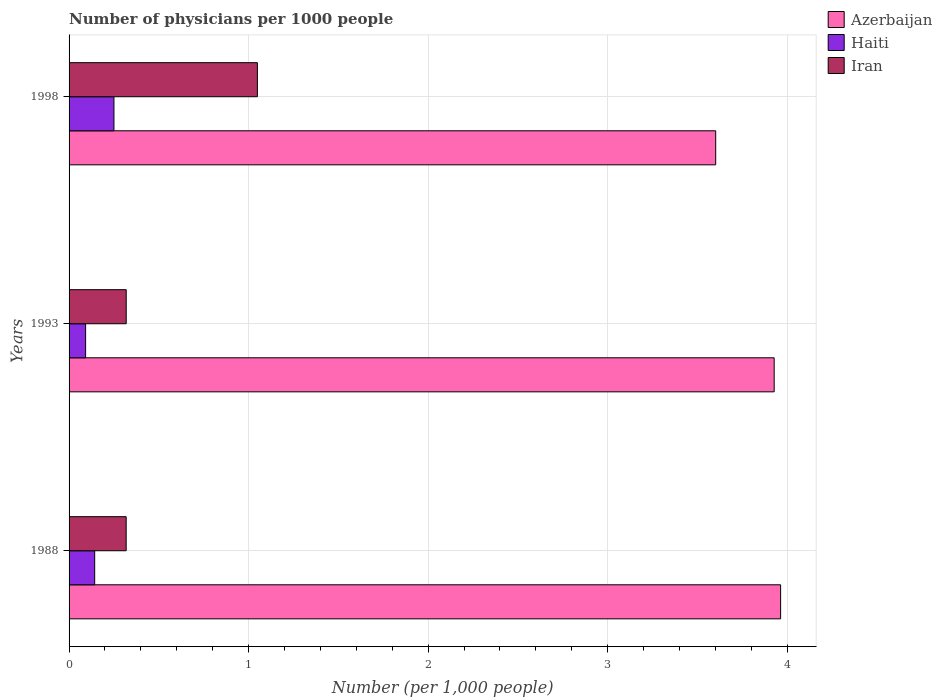Are the number of bars per tick equal to the number of legend labels?
Provide a succinct answer. Yes. How many bars are there on the 3rd tick from the bottom?
Your answer should be very brief. 3. What is the label of the 2nd group of bars from the top?
Make the answer very short. 1993. In how many cases, is the number of bars for a given year not equal to the number of legend labels?
Keep it short and to the point. 0. What is the number of physicians in Azerbaijan in 1988?
Ensure brevity in your answer.  3.96. Across all years, what is the maximum number of physicians in Haiti?
Offer a very short reply. 0.25. Across all years, what is the minimum number of physicians in Haiti?
Make the answer very short. 0.09. What is the total number of physicians in Azerbaijan in the graph?
Ensure brevity in your answer.  11.49. What is the difference between the number of physicians in Azerbaijan in 1988 and that in 1998?
Provide a short and direct response. 0.36. What is the difference between the number of physicians in Iran in 1993 and the number of physicians in Azerbaijan in 1998?
Offer a terse response. -3.28. What is the average number of physicians in Iran per year?
Your answer should be compact. 0.56. In the year 1998, what is the difference between the number of physicians in Iran and number of physicians in Azerbaijan?
Your answer should be compact. -2.55. In how many years, is the number of physicians in Iran greater than 2.4 ?
Make the answer very short. 0. What is the ratio of the number of physicians in Azerbaijan in 1993 to that in 1998?
Keep it short and to the point. 1.09. Is the difference between the number of physicians in Iran in 1993 and 1998 greater than the difference between the number of physicians in Azerbaijan in 1993 and 1998?
Offer a terse response. No. What is the difference between the highest and the second highest number of physicians in Haiti?
Provide a short and direct response. 0.11. What is the difference between the highest and the lowest number of physicians in Haiti?
Provide a short and direct response. 0.16. Is the sum of the number of physicians in Iran in 1988 and 1998 greater than the maximum number of physicians in Azerbaijan across all years?
Your response must be concise. No. What does the 3rd bar from the top in 1988 represents?
Ensure brevity in your answer.  Azerbaijan. What does the 2nd bar from the bottom in 1993 represents?
Give a very brief answer. Haiti. Does the graph contain grids?
Your answer should be very brief. Yes. How many legend labels are there?
Offer a very short reply. 3. What is the title of the graph?
Ensure brevity in your answer.  Number of physicians per 1000 people. What is the label or title of the X-axis?
Ensure brevity in your answer.  Number (per 1,0 people). What is the Number (per 1,000 people) of Azerbaijan in 1988?
Offer a very short reply. 3.96. What is the Number (per 1,000 people) in Haiti in 1988?
Make the answer very short. 0.14. What is the Number (per 1,000 people) of Iran in 1988?
Your response must be concise. 0.32. What is the Number (per 1,000 people) of Azerbaijan in 1993?
Ensure brevity in your answer.  3.93. What is the Number (per 1,000 people) in Haiti in 1993?
Offer a very short reply. 0.09. What is the Number (per 1,000 people) of Iran in 1993?
Provide a succinct answer. 0.32. What is the Number (per 1,000 people) in Azerbaijan in 1998?
Ensure brevity in your answer.  3.6. What is the Number (per 1,000 people) of Iran in 1998?
Keep it short and to the point. 1.05. Across all years, what is the maximum Number (per 1,000 people) of Azerbaijan?
Offer a very short reply. 3.96. Across all years, what is the maximum Number (per 1,000 people) of Iran?
Your response must be concise. 1.05. Across all years, what is the minimum Number (per 1,000 people) in Azerbaijan?
Your answer should be compact. 3.6. Across all years, what is the minimum Number (per 1,000 people) in Haiti?
Provide a short and direct response. 0.09. Across all years, what is the minimum Number (per 1,000 people) in Iran?
Ensure brevity in your answer.  0.32. What is the total Number (per 1,000 people) of Azerbaijan in the graph?
Provide a succinct answer. 11.49. What is the total Number (per 1,000 people) of Haiti in the graph?
Provide a succinct answer. 0.48. What is the total Number (per 1,000 people) of Iran in the graph?
Give a very brief answer. 1.69. What is the difference between the Number (per 1,000 people) in Azerbaijan in 1988 and that in 1993?
Offer a terse response. 0.04. What is the difference between the Number (per 1,000 people) of Haiti in 1988 and that in 1993?
Provide a short and direct response. 0.05. What is the difference between the Number (per 1,000 people) in Iran in 1988 and that in 1993?
Provide a succinct answer. -0. What is the difference between the Number (per 1,000 people) in Azerbaijan in 1988 and that in 1998?
Ensure brevity in your answer.  0.36. What is the difference between the Number (per 1,000 people) in Haiti in 1988 and that in 1998?
Your response must be concise. -0.11. What is the difference between the Number (per 1,000 people) of Iran in 1988 and that in 1998?
Provide a succinct answer. -0.73. What is the difference between the Number (per 1,000 people) of Azerbaijan in 1993 and that in 1998?
Keep it short and to the point. 0.33. What is the difference between the Number (per 1,000 people) of Haiti in 1993 and that in 1998?
Your answer should be very brief. -0.16. What is the difference between the Number (per 1,000 people) in Iran in 1993 and that in 1998?
Offer a terse response. -0.73. What is the difference between the Number (per 1,000 people) of Azerbaijan in 1988 and the Number (per 1,000 people) of Haiti in 1993?
Your response must be concise. 3.87. What is the difference between the Number (per 1,000 people) of Azerbaijan in 1988 and the Number (per 1,000 people) of Iran in 1993?
Keep it short and to the point. 3.65. What is the difference between the Number (per 1,000 people) of Haiti in 1988 and the Number (per 1,000 people) of Iran in 1993?
Give a very brief answer. -0.18. What is the difference between the Number (per 1,000 people) of Azerbaijan in 1988 and the Number (per 1,000 people) of Haiti in 1998?
Your answer should be very brief. 3.71. What is the difference between the Number (per 1,000 people) of Azerbaijan in 1988 and the Number (per 1,000 people) of Iran in 1998?
Offer a terse response. 2.91. What is the difference between the Number (per 1,000 people) in Haiti in 1988 and the Number (per 1,000 people) in Iran in 1998?
Offer a terse response. -0.91. What is the difference between the Number (per 1,000 people) of Azerbaijan in 1993 and the Number (per 1,000 people) of Haiti in 1998?
Offer a terse response. 3.68. What is the difference between the Number (per 1,000 people) in Azerbaijan in 1993 and the Number (per 1,000 people) in Iran in 1998?
Your answer should be compact. 2.88. What is the difference between the Number (per 1,000 people) in Haiti in 1993 and the Number (per 1,000 people) in Iran in 1998?
Make the answer very short. -0.96. What is the average Number (per 1,000 people) of Azerbaijan per year?
Ensure brevity in your answer.  3.83. What is the average Number (per 1,000 people) in Haiti per year?
Give a very brief answer. 0.16. What is the average Number (per 1,000 people) of Iran per year?
Your answer should be very brief. 0.56. In the year 1988, what is the difference between the Number (per 1,000 people) of Azerbaijan and Number (per 1,000 people) of Haiti?
Give a very brief answer. 3.82. In the year 1988, what is the difference between the Number (per 1,000 people) in Azerbaijan and Number (per 1,000 people) in Iran?
Offer a very short reply. 3.65. In the year 1988, what is the difference between the Number (per 1,000 people) in Haiti and Number (per 1,000 people) in Iran?
Offer a terse response. -0.18. In the year 1993, what is the difference between the Number (per 1,000 people) of Azerbaijan and Number (per 1,000 people) of Haiti?
Offer a terse response. 3.84. In the year 1993, what is the difference between the Number (per 1,000 people) in Azerbaijan and Number (per 1,000 people) in Iran?
Make the answer very short. 3.61. In the year 1993, what is the difference between the Number (per 1,000 people) of Haiti and Number (per 1,000 people) of Iran?
Your answer should be very brief. -0.23. In the year 1998, what is the difference between the Number (per 1,000 people) of Azerbaijan and Number (per 1,000 people) of Haiti?
Make the answer very short. 3.35. In the year 1998, what is the difference between the Number (per 1,000 people) in Azerbaijan and Number (per 1,000 people) in Iran?
Make the answer very short. 2.55. In the year 1998, what is the difference between the Number (per 1,000 people) in Haiti and Number (per 1,000 people) in Iran?
Provide a short and direct response. -0.8. What is the ratio of the Number (per 1,000 people) in Azerbaijan in 1988 to that in 1993?
Make the answer very short. 1.01. What is the ratio of the Number (per 1,000 people) in Haiti in 1988 to that in 1993?
Ensure brevity in your answer.  1.55. What is the ratio of the Number (per 1,000 people) in Iran in 1988 to that in 1993?
Provide a short and direct response. 1. What is the ratio of the Number (per 1,000 people) in Azerbaijan in 1988 to that in 1998?
Offer a terse response. 1.1. What is the ratio of the Number (per 1,000 people) of Haiti in 1988 to that in 1998?
Offer a terse response. 0.57. What is the ratio of the Number (per 1,000 people) in Iran in 1988 to that in 1998?
Ensure brevity in your answer.  0.3. What is the ratio of the Number (per 1,000 people) in Azerbaijan in 1993 to that in 1998?
Provide a short and direct response. 1.09. What is the ratio of the Number (per 1,000 people) of Haiti in 1993 to that in 1998?
Keep it short and to the point. 0.37. What is the ratio of the Number (per 1,000 people) of Iran in 1993 to that in 1998?
Provide a succinct answer. 0.3. What is the difference between the highest and the second highest Number (per 1,000 people) of Azerbaijan?
Keep it short and to the point. 0.04. What is the difference between the highest and the second highest Number (per 1,000 people) in Haiti?
Your answer should be compact. 0.11. What is the difference between the highest and the second highest Number (per 1,000 people) in Iran?
Your response must be concise. 0.73. What is the difference between the highest and the lowest Number (per 1,000 people) of Azerbaijan?
Offer a terse response. 0.36. What is the difference between the highest and the lowest Number (per 1,000 people) of Haiti?
Your answer should be compact. 0.16. What is the difference between the highest and the lowest Number (per 1,000 people) in Iran?
Ensure brevity in your answer.  0.73. 